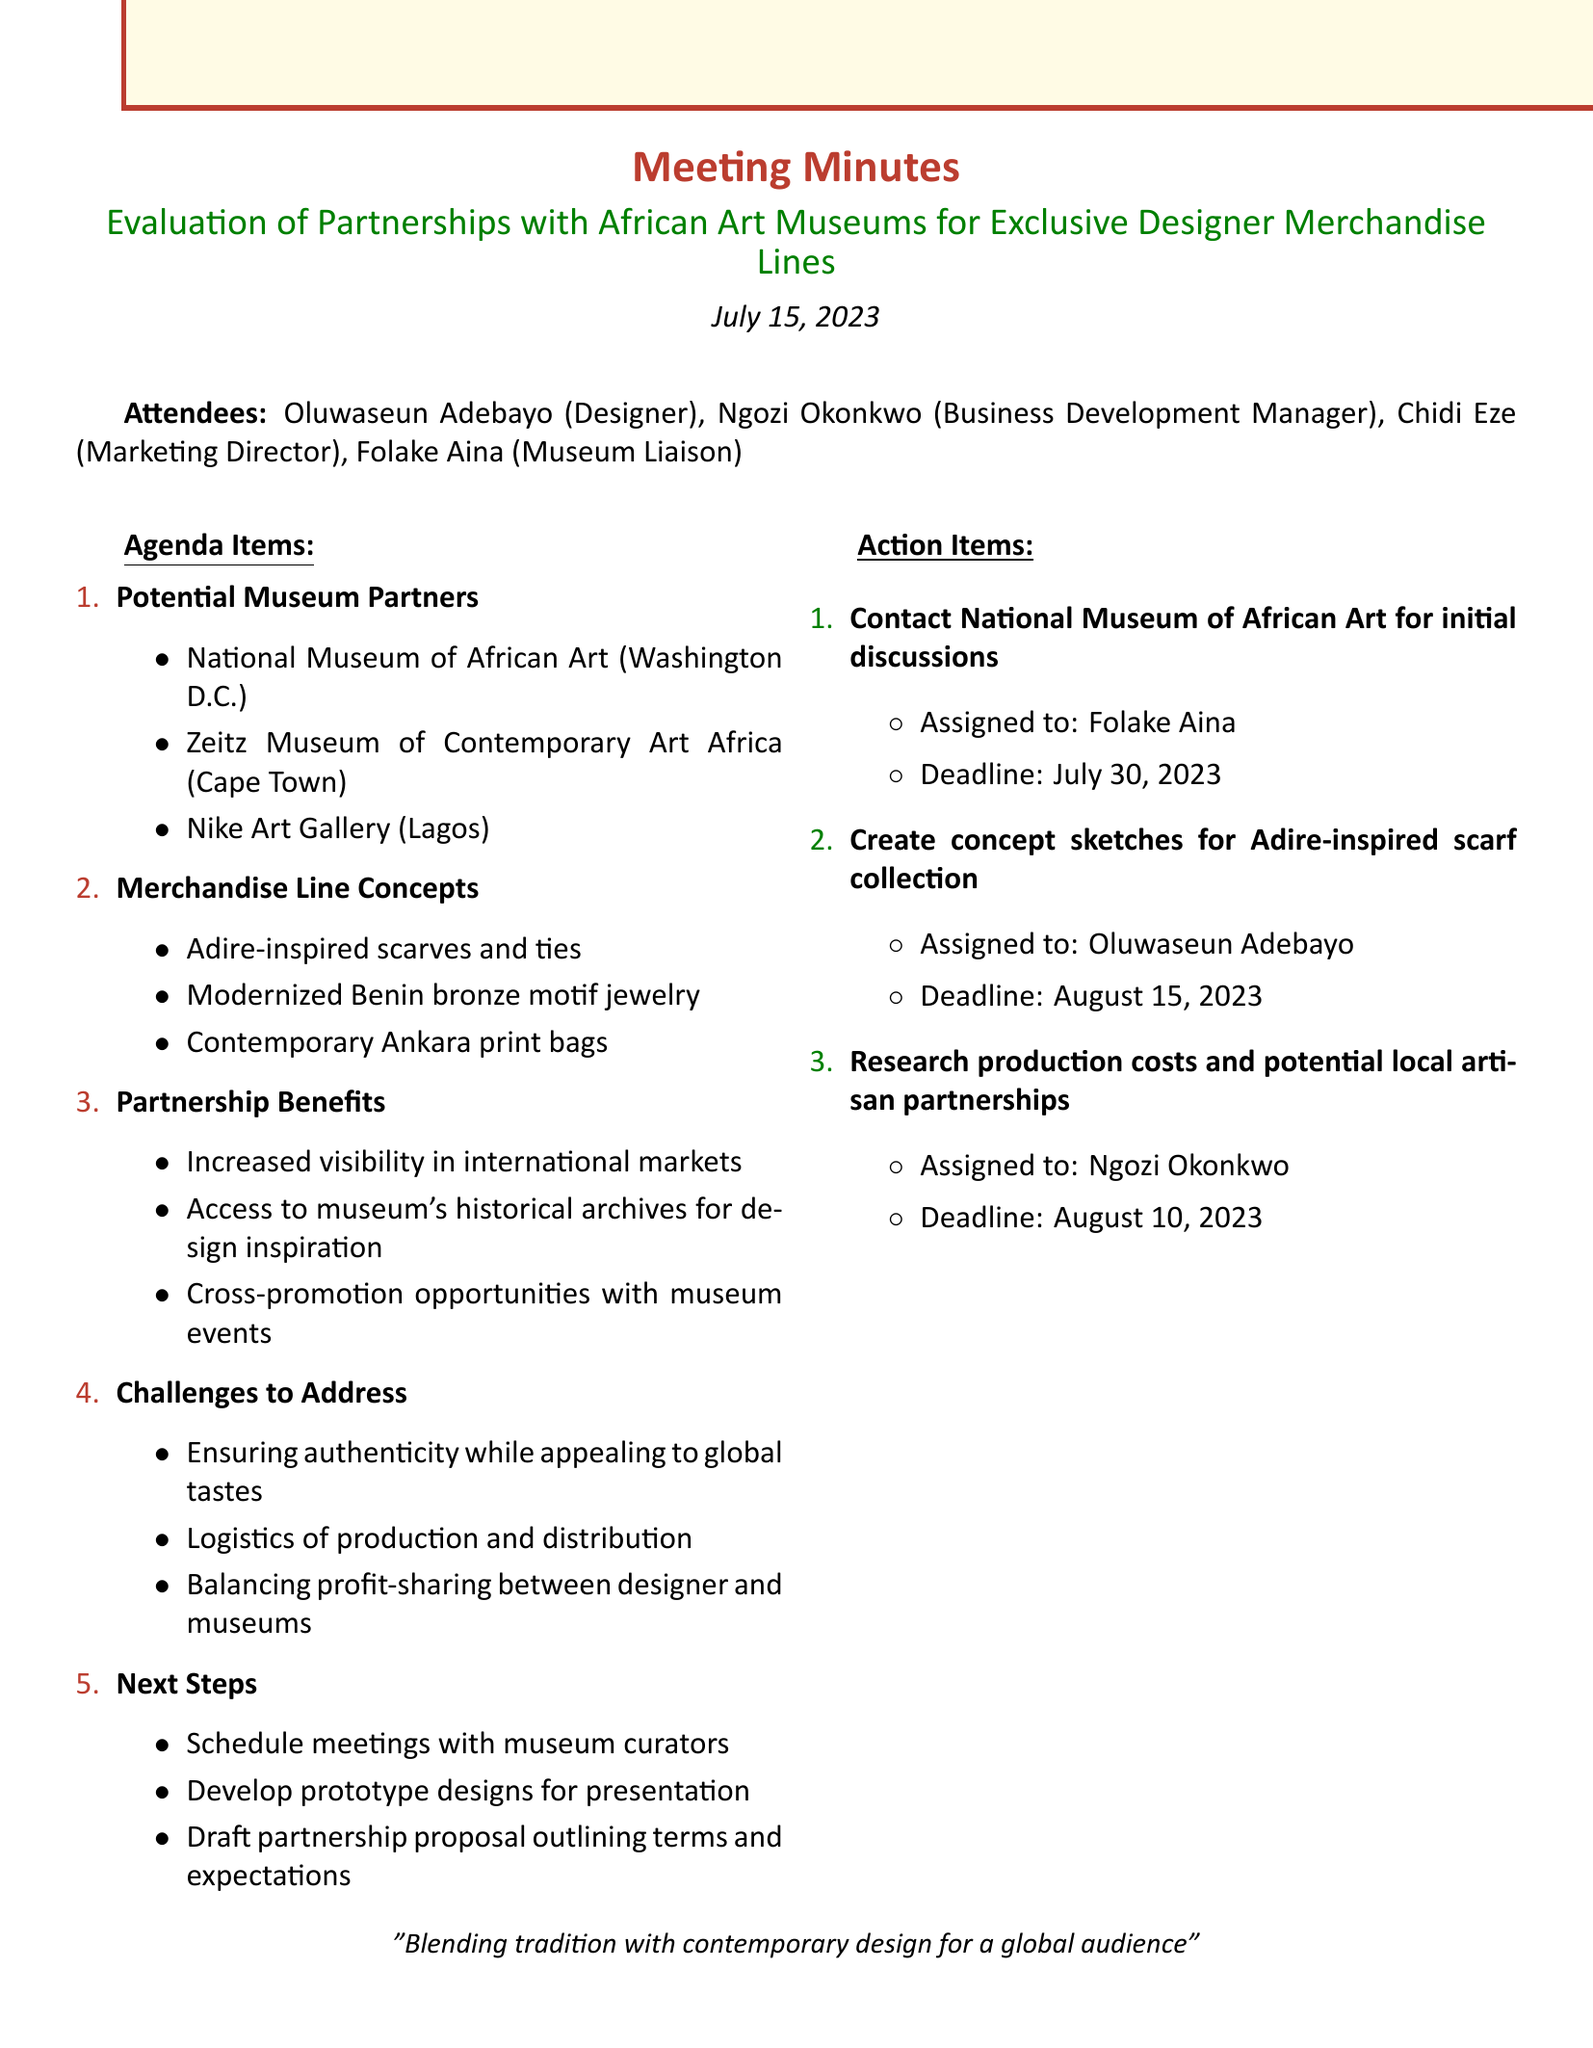What is the date of the meeting? The document states that the meeting took place on July 15, 2023.
Answer: July 15, 2023 Who is the Marketing Director? The document lists Chidi Eze as the Marketing Director among the attendees.
Answer: Chidi Eze What are two concepts for the merchandise line? The merchandise line includes Adire-inspired scarves and ties, and modernized Benin bronze motif jewelry as mentioned in the agenda.
Answer: Adire-inspired scarves and ties, modernized Benin bronze motif jewelry What is one benefit of the partnership? One benefit highlighted in the document is increased visibility in international markets.
Answer: Increased visibility in international markets What challenges need to be addressed? The challenges include ensuring authenticity while appealing to global tastes and logistics of production and distribution.
Answer: Ensuring authenticity while appealing to global tastes Who is assigned to create concept sketches for the Adire-inspired scarf collection? The action items section indicates that Oluwaseun Adebayo is responsible for creating the sketches.
Answer: Oluwaseun Adebayo What is the deadline for researching production costs? According to the action items, the deadline for this task is August 10, 2023.
Answer: August 10, 2023 What is the overall purpose of the meeting? The main focus of the meeting is to evaluate potential partnerships with African art museums for exclusive designer merchandise lines.
Answer: Evaluate potential partnerships What are the next steps discussed in the meeting? The next steps include scheduling meetings with museum curators and developing prototype designs.
Answer: Schedule meetings with museum curators, develop prototype designs 